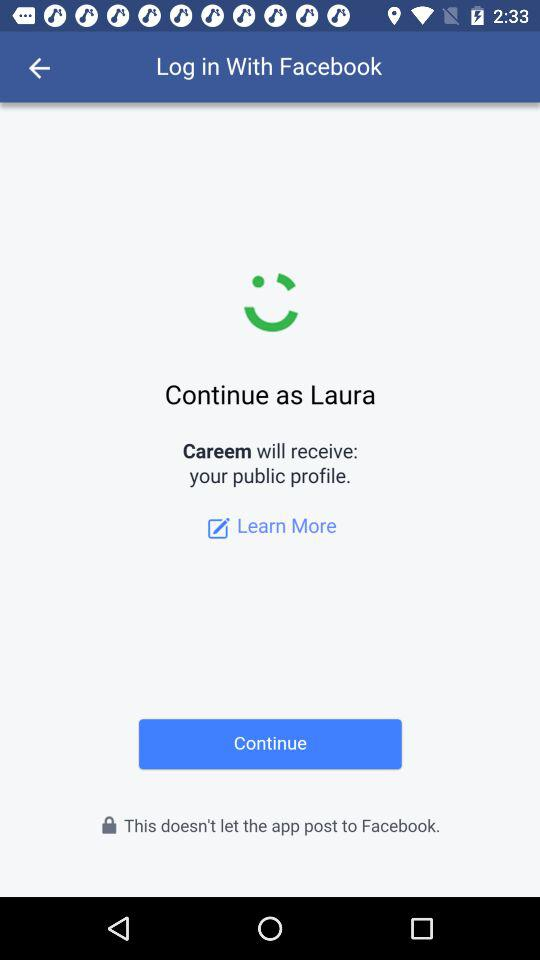What is the login name? The login name is Laura. 